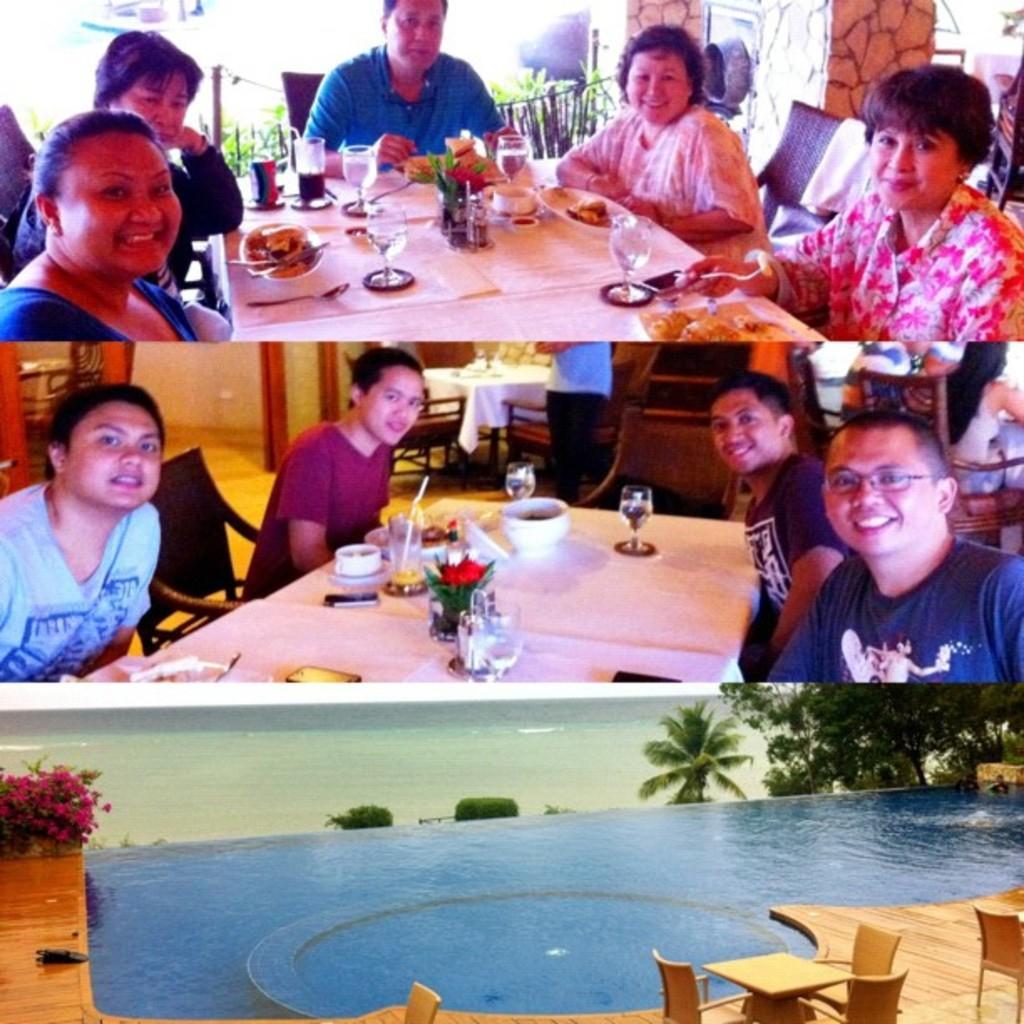Could you give a brief overview of what you see in this image? image is clicked in home where all the people are sitting and eating there are two tables in the first two images there is a third image also where there is a swimming pool and tables. In the bottom there are trees on the right side and left side there is a flower plant and in the second image on the right side there is a man with the blue shirt and spects on the left side there is a man with the sky blue color shirt they all are sitting on chairs around the table. on the table that is a glass ,bowl, flower, straw, mobile phone. In the first image the right side a woman is sitting she is wearing a floral dress and In the top A man is sitting and he is wearing blue shirt women is wearing who is on the left side is wearing blue shirt. on the table top there is a glass ,bowl and cloth and eatables 